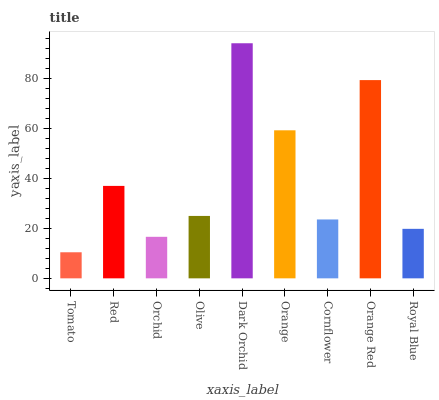Is Red the minimum?
Answer yes or no. No. Is Red the maximum?
Answer yes or no. No. Is Red greater than Tomato?
Answer yes or no. Yes. Is Tomato less than Red?
Answer yes or no. Yes. Is Tomato greater than Red?
Answer yes or no. No. Is Red less than Tomato?
Answer yes or no. No. Is Olive the high median?
Answer yes or no. Yes. Is Olive the low median?
Answer yes or no. Yes. Is Orange the high median?
Answer yes or no. No. Is Orange the low median?
Answer yes or no. No. 